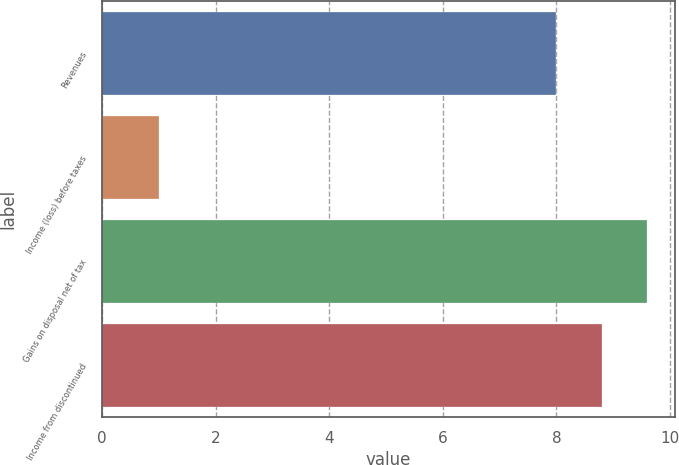<chart> <loc_0><loc_0><loc_500><loc_500><bar_chart><fcel>Revenues<fcel>Income (loss) before taxes<fcel>Gains on disposal net of tax<fcel>Income from discontinued<nl><fcel>8<fcel>1<fcel>9.6<fcel>8.8<nl></chart> 